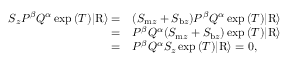<formula> <loc_0><loc_0><loc_500><loc_500>\begin{array} { r l } { S _ { z } P ^ { \beta } Q ^ { \alpha } \exp { ( T ) } | R \rangle = } & { ( S _ { m z } + S _ { b z } ) P ^ { \beta } Q ^ { \alpha } \exp { ( T ) } | R \rangle } \\ { = } & { P ^ { \beta } Q ^ { \alpha } ( S _ { m z } + S _ { b z } ) \exp { ( T ) } | R \rangle } \\ { = } & { P ^ { \beta } Q ^ { \alpha } S _ { z } \exp { ( T ) } | R \rangle = 0 , } \end{array}</formula> 